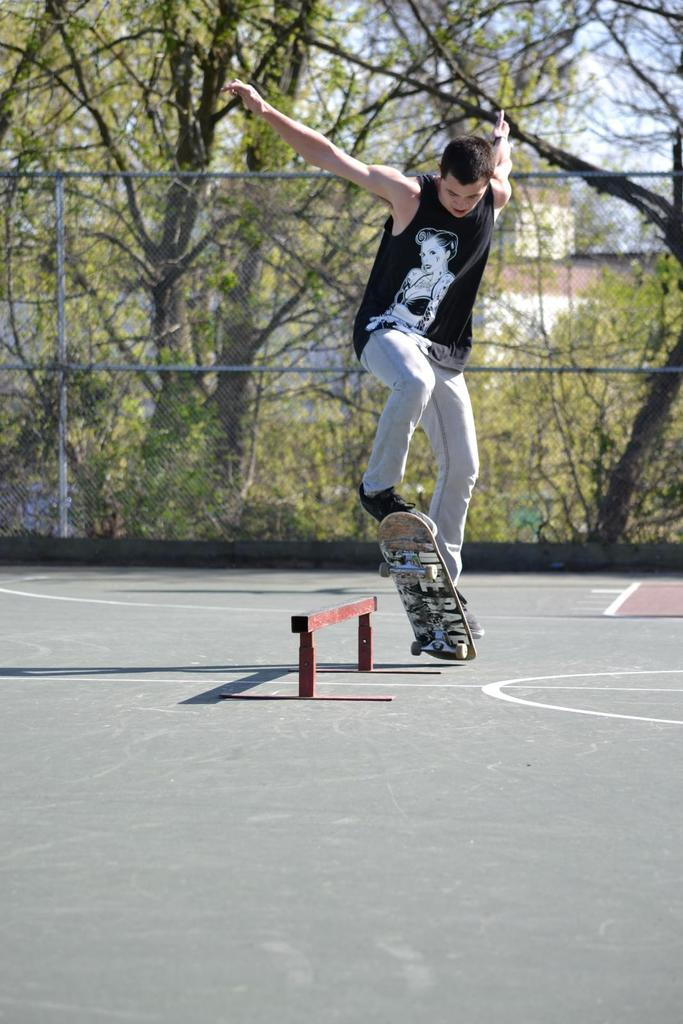What is the main subject of the image? There is a man in the image. What is the man doing in the image? The man is jumping along with a skateboard. What type of object can be seen in the image that is typically used for sitting? There is a wooden bench in the image. What type of barrier is present in the image? There is a fence in the image. What type of vegetation is visible in the image? There are trees with branches and leaves in the image. What type of voice can be heard coming from the trees in the image? There is no voice present in the image; it is a visual representation without any sound. 